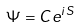<formula> <loc_0><loc_0><loc_500><loc_500>\Psi = C e ^ { i S }</formula> 